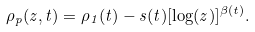<formula> <loc_0><loc_0><loc_500><loc_500>\rho _ { p } ( z , t ) = \rho _ { 1 } ( t ) - s ( t ) [ \log ( z ) ] ^ { \beta ( t ) } .</formula> 